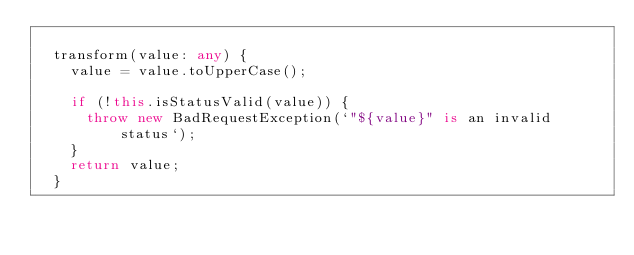Convert code to text. <code><loc_0><loc_0><loc_500><loc_500><_TypeScript_>
  transform(value: any) {
    value = value.toUpperCase();

    if (!this.isStatusValid(value)) {
      throw new BadRequestException(`"${value}" is an invalid status`);
    }
    return value;
  }</code> 